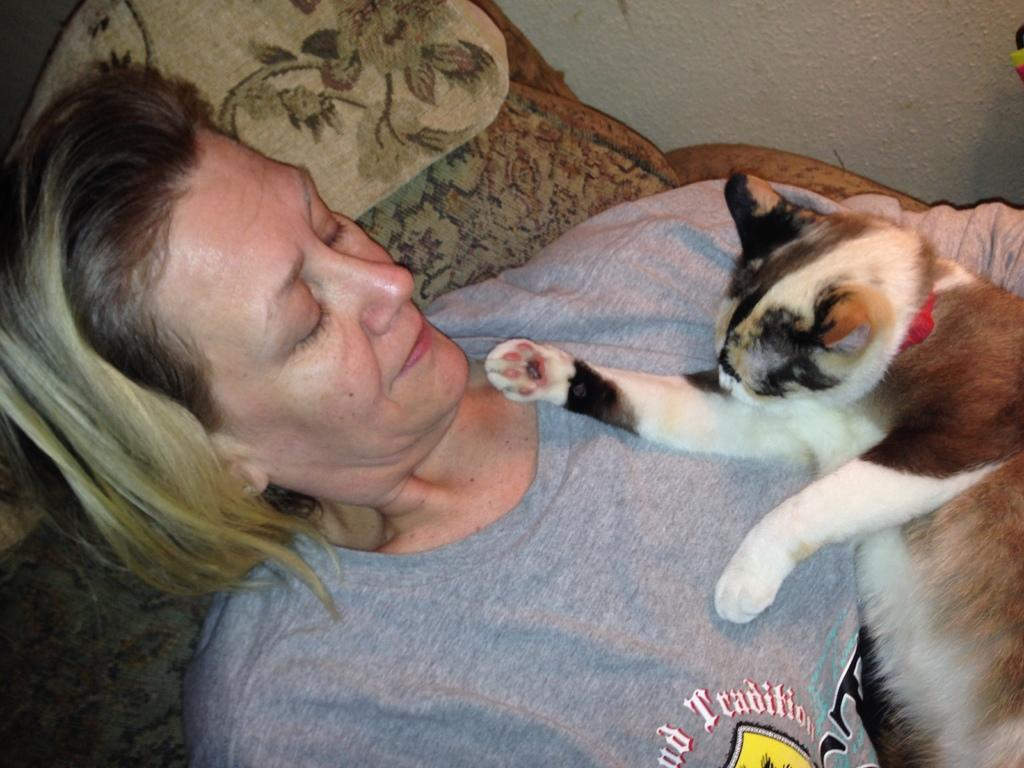What is the woman doing in the image? The woman is lying on a blanket in the image. Is there any animal present in the image? Yes, there is a cat on the woman in the image. What can be seen in the background of the image? There is a wall visible in the image. What type of leaf is being used as linen in the image? There is no leaf or linen present in the image; the woman is lying on a blanket. How does the wind affect the cat's position on the woman in the image? There is no mention of wind in the image, and the cat's position is not affected by any wind. 